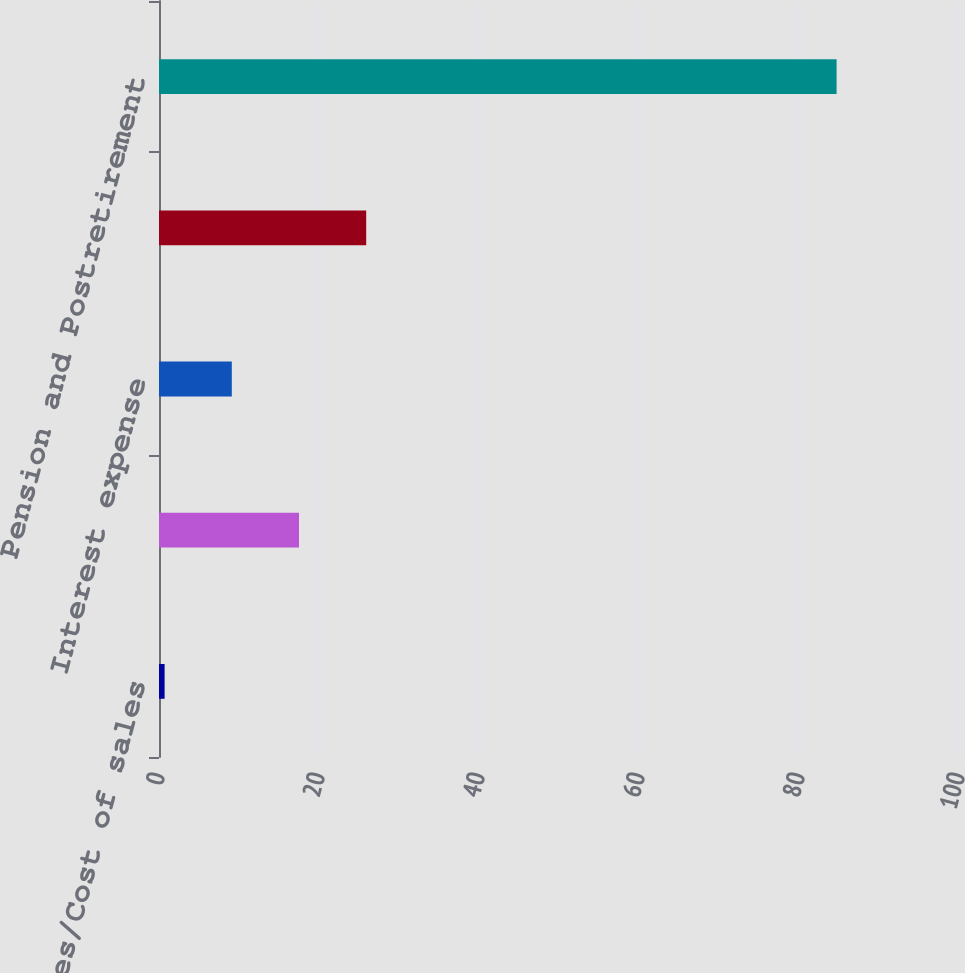Convert chart. <chart><loc_0><loc_0><loc_500><loc_500><bar_chart><fcel>Sales/Cost of sales<fcel>Other income (expense) net<fcel>Interest expense<fcel>Total (Gain) Loss on Cash Flow<fcel>Pension and Postretirement<nl><fcel>0.7<fcel>17.5<fcel>9.1<fcel>25.9<fcel>84.7<nl></chart> 